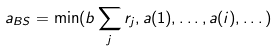<formula> <loc_0><loc_0><loc_500><loc_500>a _ { B S } = \min ( b \sum _ { j } r _ { j } , a ( 1 ) , \dots , a ( i ) , \dots )</formula> 